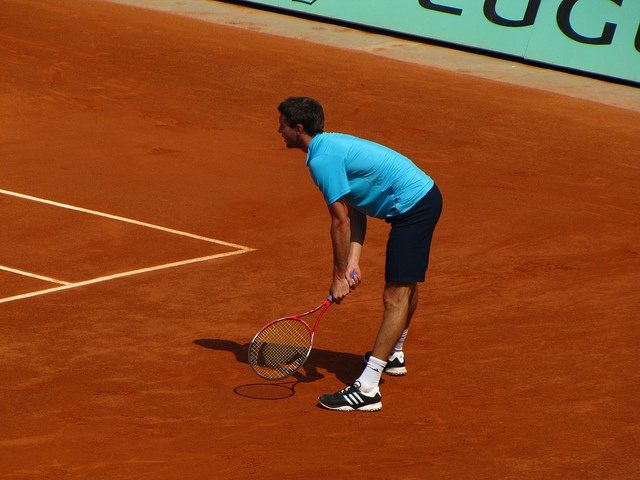Describe the objects in this image and their specific colors. I can see people in brown, black, maroon, and lightblue tones and tennis racket in brown, maroon, and black tones in this image. 